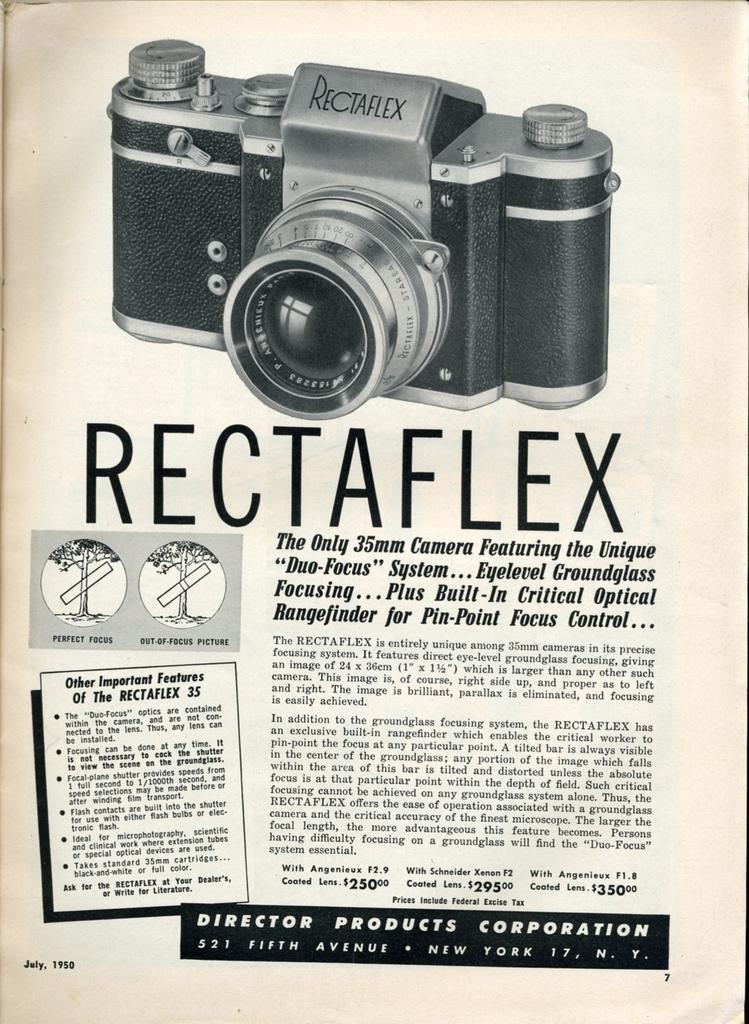Describe this image in one or two sentences. This picture shows a paper. We see a camera and text on it. 